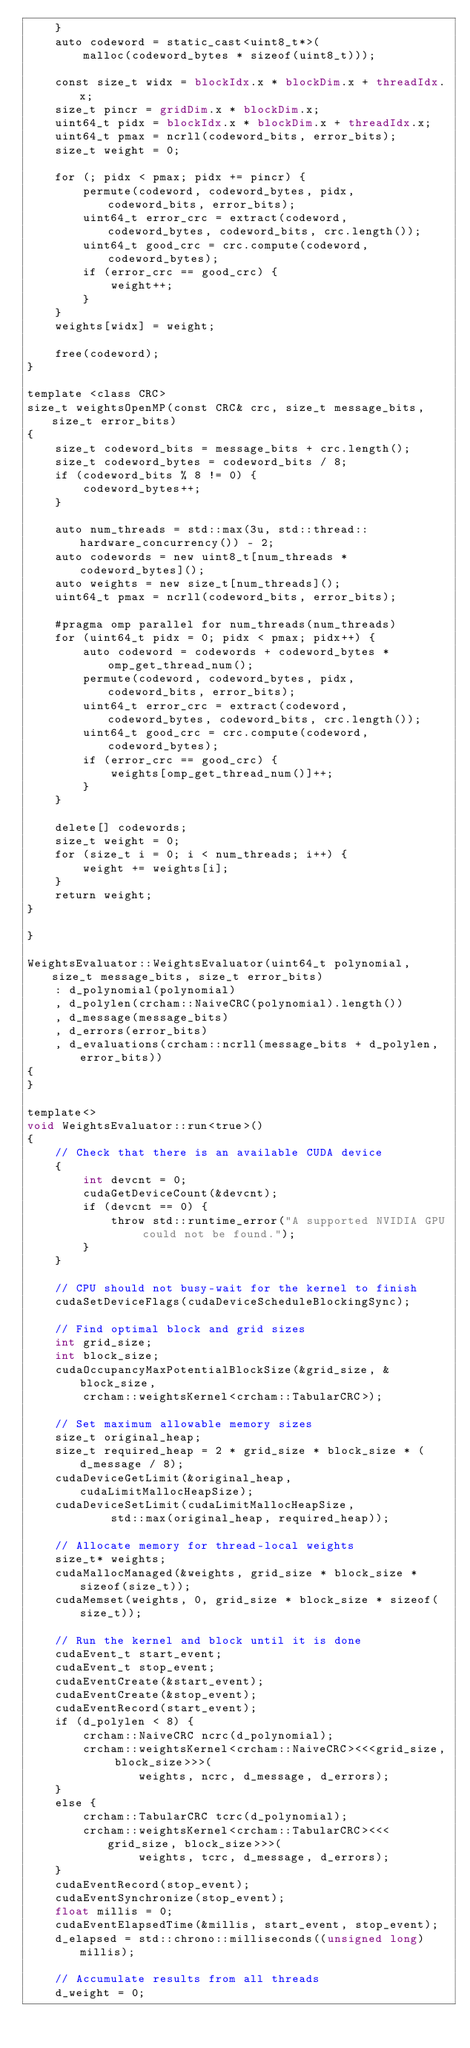<code> <loc_0><loc_0><loc_500><loc_500><_Cuda_>    }
    auto codeword = static_cast<uint8_t*>(
        malloc(codeword_bytes * sizeof(uint8_t)));

    const size_t widx = blockIdx.x * blockDim.x + threadIdx.x;
    size_t pincr = gridDim.x * blockDim.x; 
    uint64_t pidx = blockIdx.x * blockDim.x + threadIdx.x; 
    uint64_t pmax = ncrll(codeword_bits, error_bits);
    size_t weight = 0;

    for (; pidx < pmax; pidx += pincr) {
        permute(codeword, codeword_bytes, pidx, codeword_bits, error_bits);
        uint64_t error_crc = extract(codeword, codeword_bytes, codeword_bits, crc.length());
        uint64_t good_crc = crc.compute(codeword, codeword_bytes);
        if (error_crc == good_crc) {
            weight++;
        }
    }
    weights[widx] = weight;

    free(codeword);
}

template <class CRC>
size_t weightsOpenMP(const CRC& crc, size_t message_bits, size_t error_bits) 
{
    size_t codeword_bits = message_bits + crc.length();
    size_t codeword_bytes = codeword_bits / 8;
    if (codeword_bits % 8 != 0) {
        codeword_bytes++;
    }

    auto num_threads = std::max(3u, std::thread::hardware_concurrency()) - 2;
    auto codewords = new uint8_t[num_threads * codeword_bytes]();
    auto weights = new size_t[num_threads]();
    uint64_t pmax = ncrll(codeword_bits, error_bits);

    #pragma omp parallel for num_threads(num_threads)
    for (uint64_t pidx = 0; pidx < pmax; pidx++) {
        auto codeword = codewords + codeword_bytes * omp_get_thread_num();
        permute(codeword, codeword_bytes, pidx, codeword_bits, error_bits);
        uint64_t error_crc = extract(codeword, codeword_bytes, codeword_bits, crc.length());
        uint64_t good_crc = crc.compute(codeword, codeword_bytes);
        if (error_crc == good_crc) {
            weights[omp_get_thread_num()]++;
        }
    }

    delete[] codewords;
    size_t weight = 0;
    for (size_t i = 0; i < num_threads; i++) {
        weight += weights[i];
    }
    return weight;
}

}

WeightsEvaluator::WeightsEvaluator(uint64_t polynomial, size_t message_bits, size_t error_bits) 
    : d_polynomial(polynomial)
    , d_polylen(crcham::NaiveCRC(polynomial).length())
    , d_message(message_bits)
    , d_errors(error_bits)
    , d_evaluations(crcham::ncrll(message_bits + d_polylen, error_bits))
{
}

template<>
void WeightsEvaluator::run<true>()
{
    // Check that there is an available CUDA device
    {
        int devcnt = 0;
        cudaGetDeviceCount(&devcnt);
        if (devcnt == 0) {
            throw std::runtime_error("A supported NVIDIA GPU could not be found.");
        }
    }

    // CPU should not busy-wait for the kernel to finish
    cudaSetDeviceFlags(cudaDeviceScheduleBlockingSync);

    // Find optimal block and grid sizes
    int grid_size;
    int block_size;
    cudaOccupancyMaxPotentialBlockSize(&grid_size, &block_size, 
        crcham::weightsKernel<crcham::TabularCRC>);

    // Set maximum allowable memory sizes
    size_t original_heap;
    size_t required_heap = 2 * grid_size * block_size * (d_message / 8);
    cudaDeviceGetLimit(&original_heap, cudaLimitMallocHeapSize);
    cudaDeviceSetLimit(cudaLimitMallocHeapSize, 
            std::max(original_heap, required_heap));

    // Allocate memory for thread-local weights
    size_t* weights;
    cudaMallocManaged(&weights, grid_size * block_size * sizeof(size_t));
    cudaMemset(weights, 0, grid_size * block_size * sizeof(size_t));

    // Run the kernel and block until it is done
    cudaEvent_t start_event; 
    cudaEvent_t stop_event;
    cudaEventCreate(&start_event);
    cudaEventCreate(&stop_event);
    cudaEventRecord(start_event);
    if (d_polylen < 8) {
        crcham::NaiveCRC ncrc(d_polynomial);
        crcham::weightsKernel<crcham::NaiveCRC><<<grid_size, block_size>>>(
                weights, ncrc, d_message, d_errors); 
    }
    else {
        crcham::TabularCRC tcrc(d_polynomial);
        crcham::weightsKernel<crcham::TabularCRC><<<grid_size, block_size>>>(
                weights, tcrc, d_message, d_errors); 
    }
    cudaEventRecord(stop_event);
    cudaEventSynchronize(stop_event);
    float millis = 0;
    cudaEventElapsedTime(&millis, start_event, stop_event);
    d_elapsed = std::chrono::milliseconds((unsigned long) millis);

    // Accumulate results from all threads
    d_weight = 0;</code> 